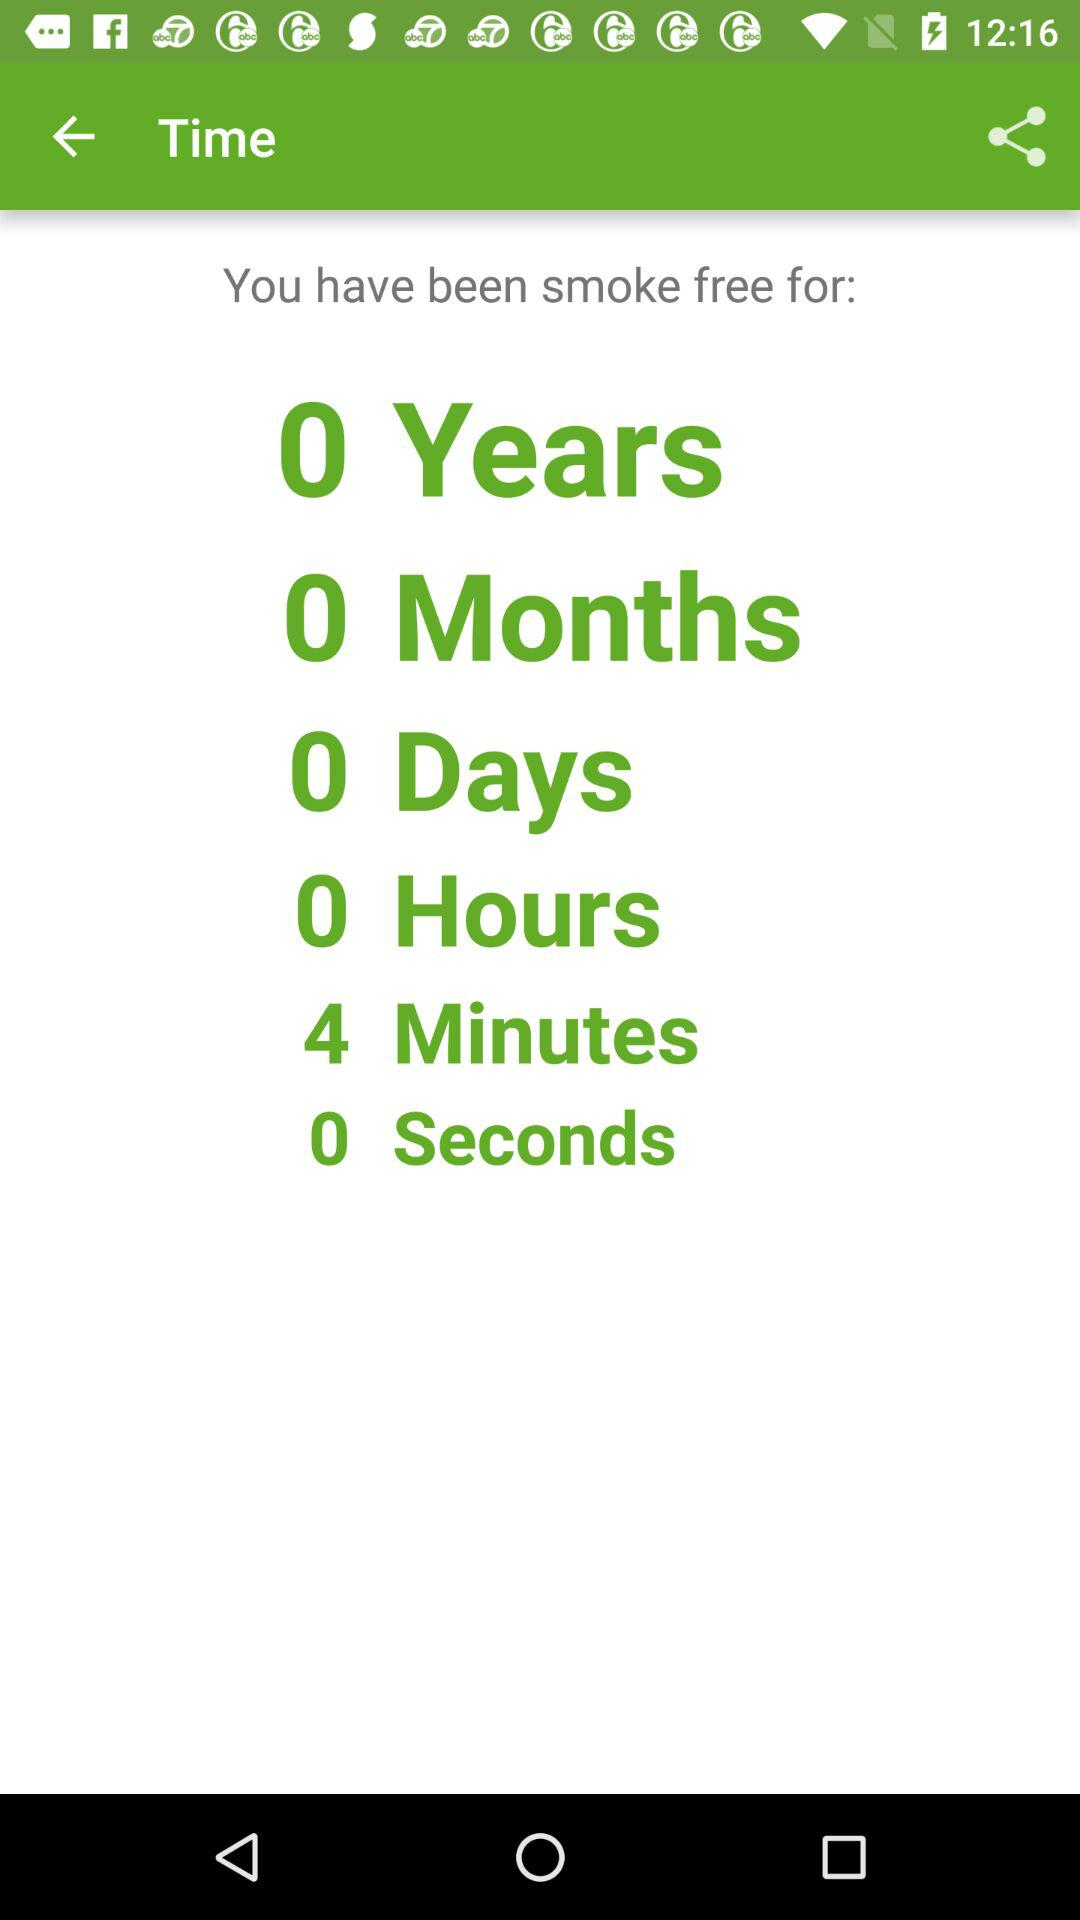I've been smoke-free for how many minutes?
When the provided information is insufficient, respond with <no answer>. <no answer> 